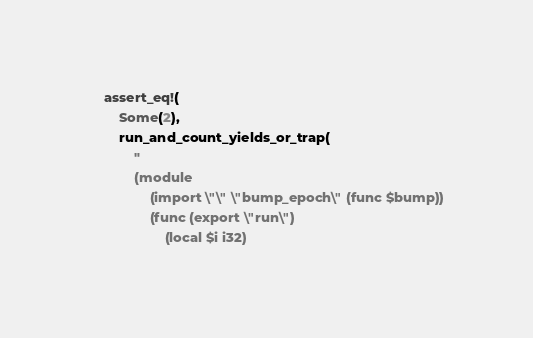Convert code to text. <code><loc_0><loc_0><loc_500><loc_500><_Rust_>    assert_eq!(
        Some(2),
        run_and_count_yields_or_trap(
            "
            (module
                (import \"\" \"bump_epoch\" (func $bump))
                (func (export \"run\")
                    (local $i i32)</code> 